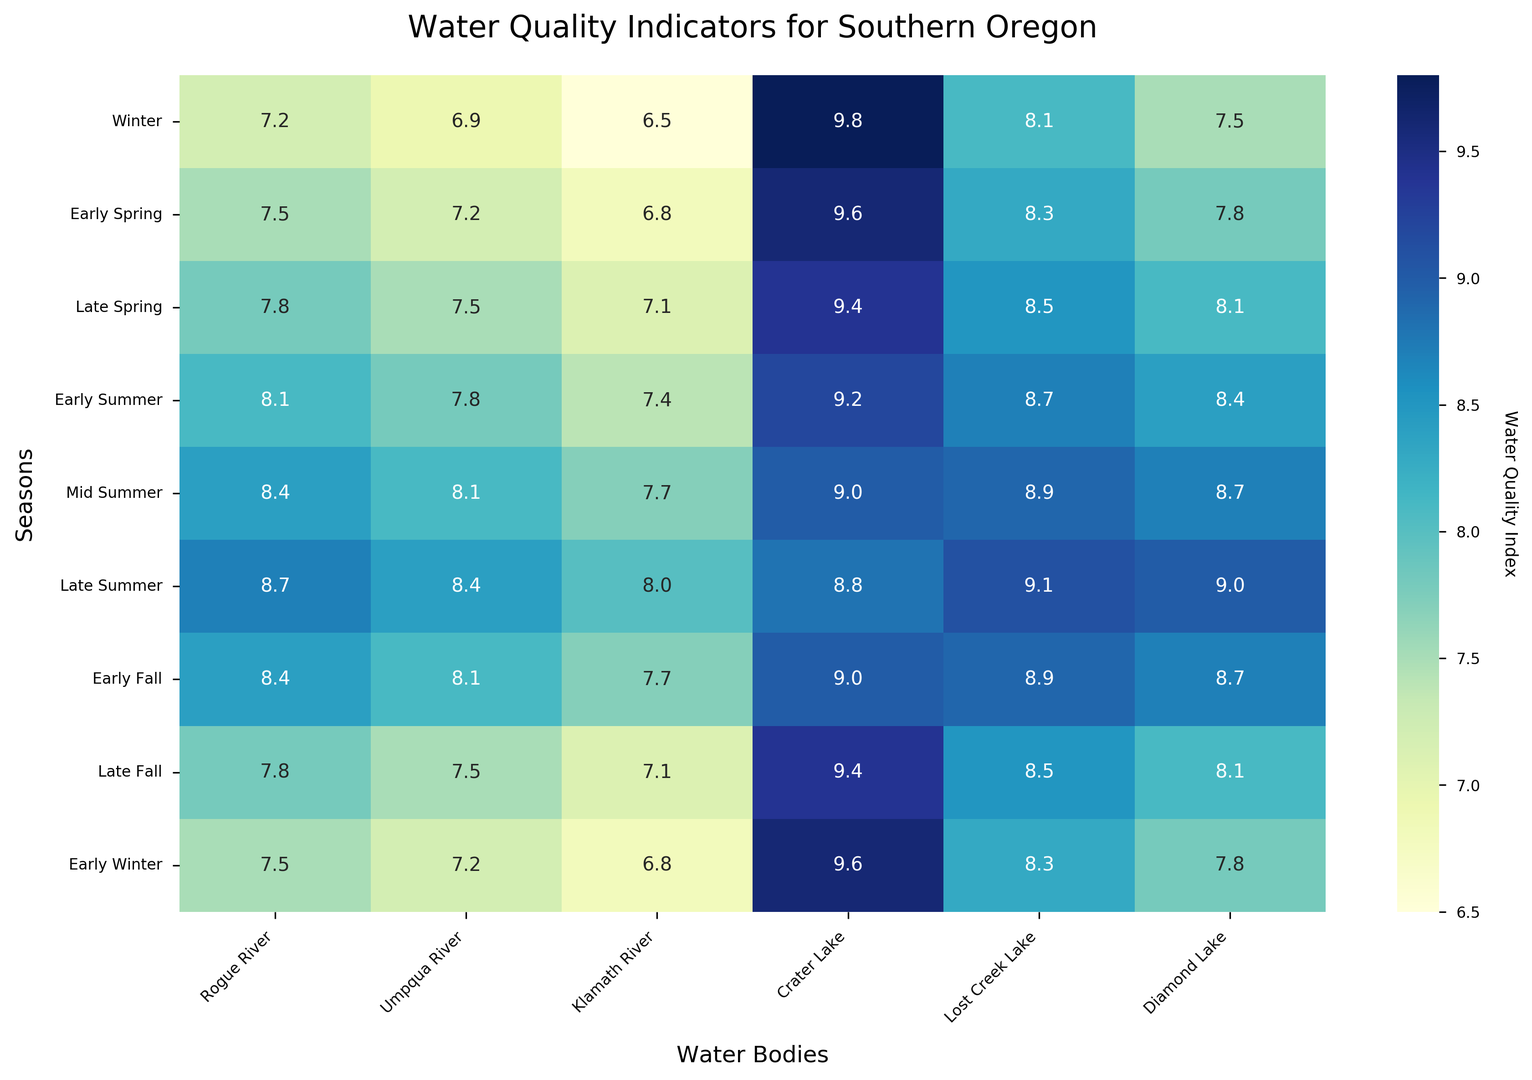Which water body has the highest water quality index in Mid Summer? To identify the water body with the highest water quality index in Mid Summer, locate the corresponding row labeled "Mid Summer" and find the maximum value among the columns for water bodies. The highest value in that row is 9.1 for Lost Creek Lake.
Answer: Lost Creek Lake Which season shows the lowest water quality index for the Klamath River? To find the lowest water quality index for the Klamath River, look down the column labeled "Klamath River" and identify the minimum value. The lowest number is 6.5 during Winter.
Answer: Winter What is the average water quality index for Crater Lake across all seasons? To calculate the average water quality index for Crater Lake, sum all values in the "Crater Lake" column and divide by the number of seasons. (9.8 + 9.6 + 9.4 + 9.2 + 9.0 + 8.8 + 9.0 + 9.4 + 9.6) / 9 = 9.31.
Answer: 9.31 Compare the water quality index of Early Summer and Late Summer for Diamond Lake. Which one is higher? To compare the values for Early Summer and Late Summer for Diamond Lake, find these rows and compare the two numbers under "Diamond Lake". The values are 8.4 for Early Summer and 9.0 for Late Summer. Therefore, Late Summer is higher.
Answer: Late Summer What is the change in water quality index from Early Spring to Late Summer in Rogue River? To calculate the change in water quality index from Early Spring to Late Summer in Rogue River, subtract the Early Spring value from the Late Summer value. 8.7 (Late Summer) - 7.5 (Early Spring) = 1.2.
Answer: 1.2 Which water body has the most stable water quality index across different seasons, indicated by the smallest range? To determine which water body has the most stable water quality, find the range for each water body (max - min value) and compare them. Crater Lake shows values between 8.8 and 9.8, so its range is the smallest (1.0).
Answer: Crater Lake In which season does Lost Creek Lake peak in terms of water quality index? To find when Lost Creek Lake peaks, look for the maximum value down the "Lost Creek Lake" column. The highest number, 9.1, is seen during Late Summer.
Answer: Late Summer How does the water quality of Umpqua River in Early Fall compare to that in Early Spring? To compare the water quality index of the Umpqua River in Early Fall and Early Spring, locate these two rows and compare the values in the "Umpqua River" column. Both values are 8.1 in Early Fall and 7.2 in Early Spring, so Early Fall is higher.
Answer: Early Fall Calculate the overall average water quality index across all water bodies for Mid Summer. To find the overall average for Mid Summer, sum all values in the Mid Summer row and divide by the number of water bodies: (8.4 + 8.1 + 7.7 + 9.0 + 8.9 + 8.7) / 6 = 8.47.
Answer: 8.47 